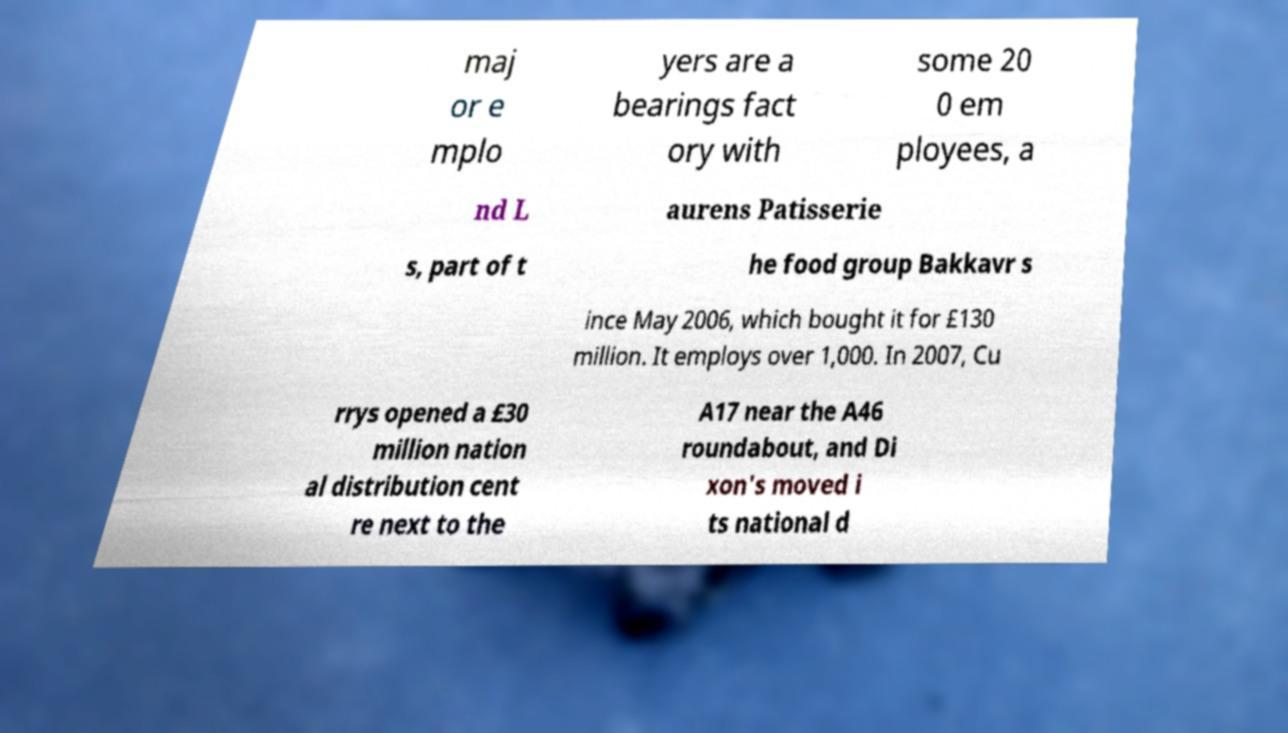Can you accurately transcribe the text from the provided image for me? maj or e mplo yers are a bearings fact ory with some 20 0 em ployees, a nd L aurens Patisserie s, part of t he food group Bakkavr s ince May 2006, which bought it for £130 million. It employs over 1,000. In 2007, Cu rrys opened a £30 million nation al distribution cent re next to the A17 near the A46 roundabout, and Di xon's moved i ts national d 